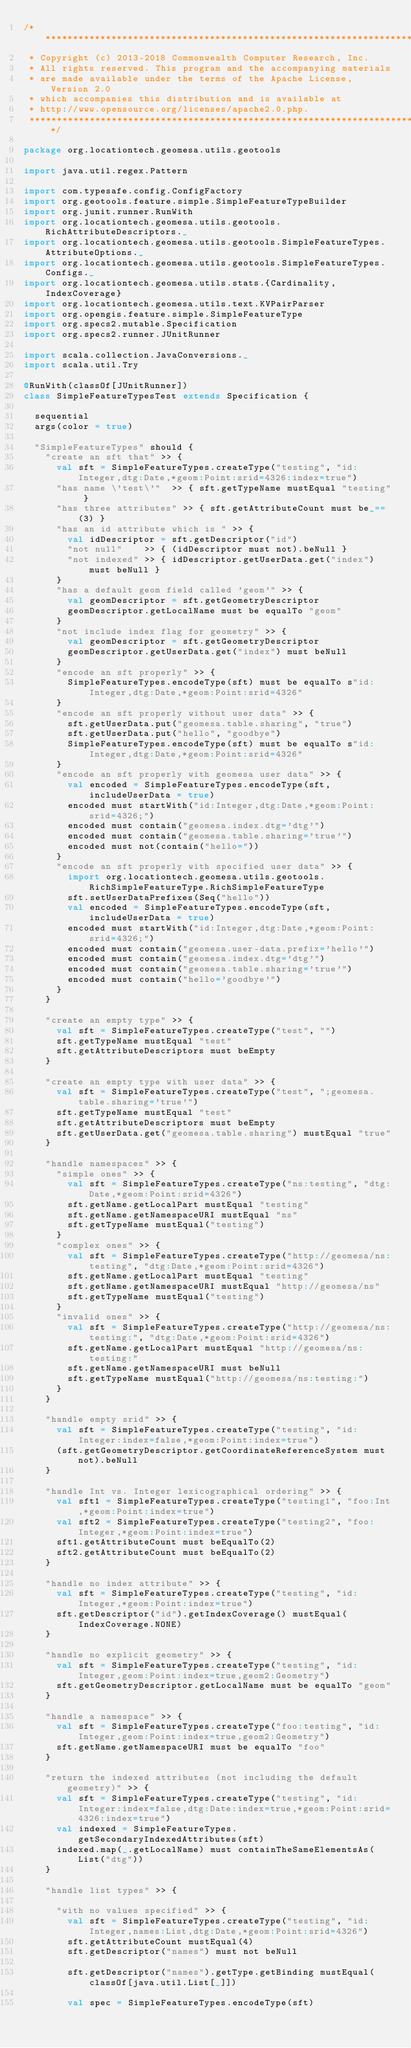Convert code to text. <code><loc_0><loc_0><loc_500><loc_500><_Scala_>/***********************************************************************
 * Copyright (c) 2013-2018 Commonwealth Computer Research, Inc.
 * All rights reserved. This program and the accompanying materials
 * are made available under the terms of the Apache License, Version 2.0
 * which accompanies this distribution and is available at
 * http://www.opensource.org/licenses/apache2.0.php.
 ***********************************************************************/

package org.locationtech.geomesa.utils.geotools

import java.util.regex.Pattern

import com.typesafe.config.ConfigFactory
import org.geotools.feature.simple.SimpleFeatureTypeBuilder
import org.junit.runner.RunWith
import org.locationtech.geomesa.utils.geotools.RichAttributeDescriptors._
import org.locationtech.geomesa.utils.geotools.SimpleFeatureTypes.AttributeOptions._
import org.locationtech.geomesa.utils.geotools.SimpleFeatureTypes.Configs._
import org.locationtech.geomesa.utils.stats.{Cardinality, IndexCoverage}
import org.locationtech.geomesa.utils.text.KVPairParser
import org.opengis.feature.simple.SimpleFeatureType
import org.specs2.mutable.Specification
import org.specs2.runner.JUnitRunner

import scala.collection.JavaConversions._
import scala.util.Try

@RunWith(classOf[JUnitRunner])
class SimpleFeatureTypesTest extends Specification {

  sequential
  args(color = true)

  "SimpleFeatureTypes" should {
    "create an sft that" >> {
      val sft = SimpleFeatureTypes.createType("testing", "id:Integer,dtg:Date,*geom:Point:srid=4326:index=true")
      "has name \'test\'"  >> { sft.getTypeName mustEqual "testing" }
      "has three attributes" >> { sft.getAttributeCount must be_==(3) }
      "has an id attribute which is " >> {
        val idDescriptor = sft.getDescriptor("id")
        "not null"    >> { (idDescriptor must not).beNull }
        "not indexed" >> { idDescriptor.getUserData.get("index") must beNull }
      }
      "has a default geom field called 'geom'" >> {
        val geomDescriptor = sft.getGeometryDescriptor
        geomDescriptor.getLocalName must be equalTo "geom"
      }
      "not include index flag for geometry" >> {
        val geomDescriptor = sft.getGeometryDescriptor
        geomDescriptor.getUserData.get("index") must beNull
      }
      "encode an sft properly" >> {
        SimpleFeatureTypes.encodeType(sft) must be equalTo s"id:Integer,dtg:Date,*geom:Point:srid=4326"
      }
      "encode an sft properly without user data" >> {
        sft.getUserData.put("geomesa.table.sharing", "true")
        sft.getUserData.put("hello", "goodbye")
        SimpleFeatureTypes.encodeType(sft) must be equalTo s"id:Integer,dtg:Date,*geom:Point:srid=4326"
      }
      "encode an sft properly with geomesa user data" >> {
        val encoded = SimpleFeatureTypes.encodeType(sft, includeUserData = true)
        encoded must startWith("id:Integer,dtg:Date,*geom:Point:srid=4326;")
        encoded must contain("geomesa.index.dtg='dtg'")
        encoded must contain("geomesa.table.sharing='true'")
        encoded must not(contain("hello="))
      }
      "encode an sft properly with specified user data" >> {
        import org.locationtech.geomesa.utils.geotools.RichSimpleFeatureType.RichSimpleFeatureType
        sft.setUserDataPrefixes(Seq("hello"))
        val encoded = SimpleFeatureTypes.encodeType(sft, includeUserData = true)
        encoded must startWith("id:Integer,dtg:Date,*geom:Point:srid=4326;")
        encoded must contain("geomesa.user-data.prefix='hello'")
        encoded must contain("geomesa.index.dtg='dtg'")
        encoded must contain("geomesa.table.sharing='true'")
        encoded must contain("hello='goodbye'")
      }
    }

    "create an empty type" >> {
      val sft = SimpleFeatureTypes.createType("test", "")
      sft.getTypeName mustEqual "test"
      sft.getAttributeDescriptors must beEmpty
    }

    "create an empty type with user data" >> {
      val sft = SimpleFeatureTypes.createType("test", ";geomesa.table.sharing='true'")
      sft.getTypeName mustEqual "test"
      sft.getAttributeDescriptors must beEmpty
      sft.getUserData.get("geomesa.table.sharing") mustEqual "true"
    }

    "handle namespaces" >> {
      "simple ones" >> {
        val sft = SimpleFeatureTypes.createType("ns:testing", "dtg:Date,*geom:Point:srid=4326")
        sft.getName.getLocalPart mustEqual "testing"
        sft.getName.getNamespaceURI mustEqual "ns"
        sft.getTypeName mustEqual("testing")
      }
      "complex ones" >> {
        val sft = SimpleFeatureTypes.createType("http://geomesa/ns:testing", "dtg:Date,*geom:Point:srid=4326")
        sft.getName.getLocalPart mustEqual "testing"
        sft.getName.getNamespaceURI mustEqual "http://geomesa/ns"
        sft.getTypeName mustEqual("testing")
      }
      "invalid ones" >> {
        val sft = SimpleFeatureTypes.createType("http://geomesa/ns:testing:", "dtg:Date,*geom:Point:srid=4326")
        sft.getName.getLocalPart mustEqual "http://geomesa/ns:testing:"
        sft.getName.getNamespaceURI must beNull
        sft.getTypeName mustEqual("http://geomesa/ns:testing:")
      }
    }

    "handle empty srid" >> {
      val sft = SimpleFeatureTypes.createType("testing", "id:Integer:index=false,*geom:Point:index=true")
      (sft.getGeometryDescriptor.getCoordinateReferenceSystem must not).beNull
    }

    "handle Int vs. Integer lexicographical ordering" >> {
      val sft1 = SimpleFeatureTypes.createType("testing1", "foo:Int,*geom:Point:index=true")
      val sft2 = SimpleFeatureTypes.createType("testing2", "foo:Integer,*geom:Point:index=true")
      sft1.getAttributeCount must beEqualTo(2)
      sft2.getAttributeCount must beEqualTo(2)
    }

    "handle no index attribute" >> {
      val sft = SimpleFeatureTypes.createType("testing", "id:Integer,*geom:Point:index=true")
      sft.getDescriptor("id").getIndexCoverage() mustEqual(IndexCoverage.NONE)
    }

    "handle no explicit geometry" >> {
      val sft = SimpleFeatureTypes.createType("testing", "id:Integer,geom:Point:index=true,geom2:Geometry")
      sft.getGeometryDescriptor.getLocalName must be equalTo "geom"
    }

    "handle a namespace" >> {
      val sft = SimpleFeatureTypes.createType("foo:testing", "id:Integer,geom:Point:index=true,geom2:Geometry")
      sft.getName.getNamespaceURI must be equalTo "foo"
    }

    "return the indexed attributes (not including the default geometry)" >> {
      val sft = SimpleFeatureTypes.createType("testing", "id:Integer:index=false,dtg:Date:index=true,*geom:Point:srid=4326:index=true")
      val indexed = SimpleFeatureTypes.getSecondaryIndexedAttributes(sft)
      indexed.map(_.getLocalName) must containTheSameElementsAs(List("dtg"))
    }

    "handle list types" >> {

      "with no values specified" >> {
        val sft = SimpleFeatureTypes.createType("testing", "id:Integer,names:List,dtg:Date,*geom:Point:srid=4326")
        sft.getAttributeCount mustEqual(4)
        sft.getDescriptor("names") must not beNull

        sft.getDescriptor("names").getType.getBinding mustEqual(classOf[java.util.List[_]])

        val spec = SimpleFeatureTypes.encodeType(sft)</code> 